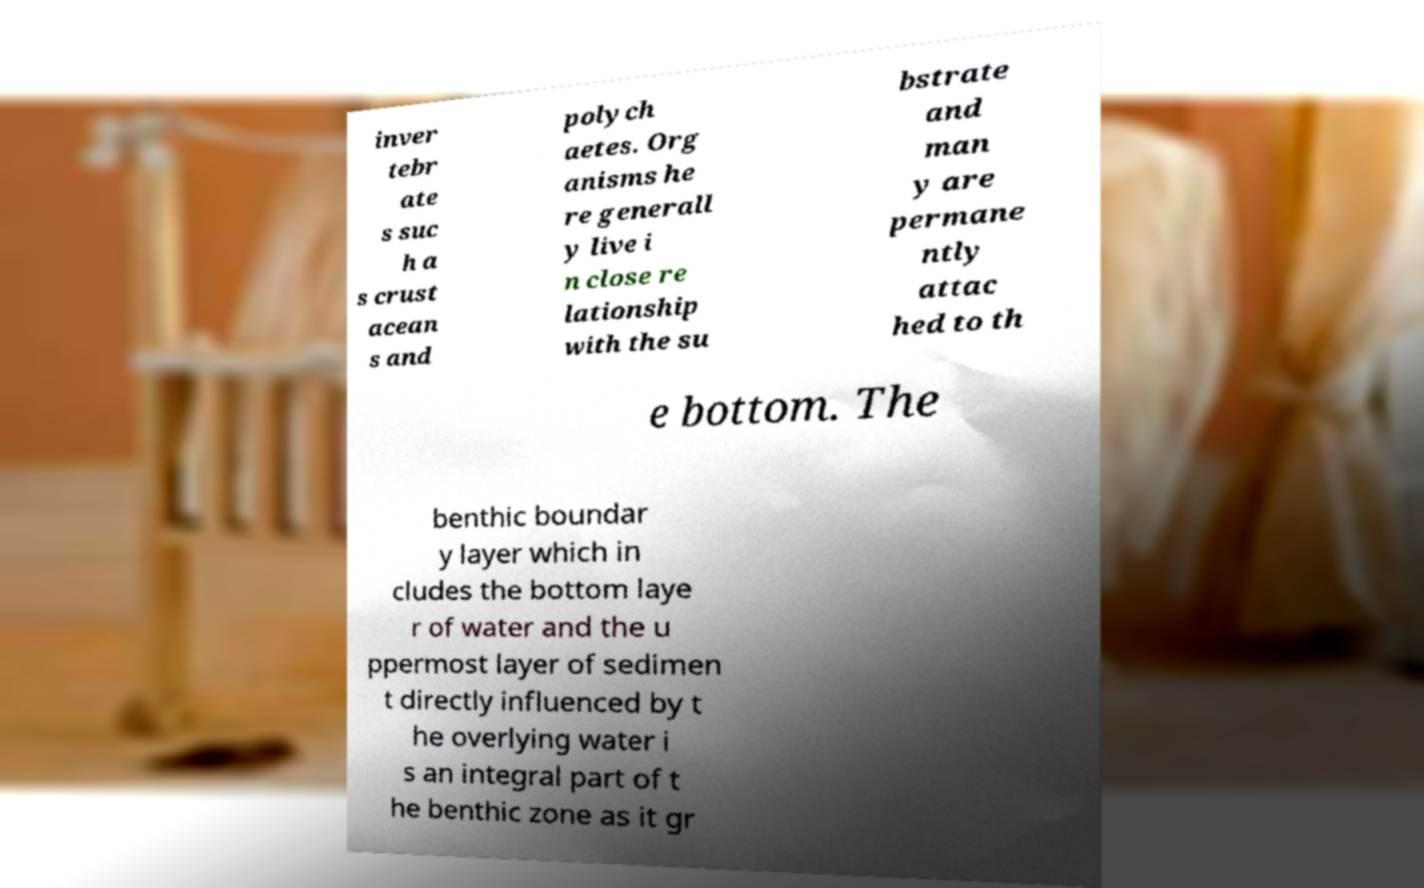I need the written content from this picture converted into text. Can you do that? inver tebr ate s suc h a s crust acean s and polych aetes. Org anisms he re generall y live i n close re lationship with the su bstrate and man y are permane ntly attac hed to th e bottom. The benthic boundar y layer which in cludes the bottom laye r of water and the u ppermost layer of sedimen t directly influenced by t he overlying water i s an integral part of t he benthic zone as it gr 